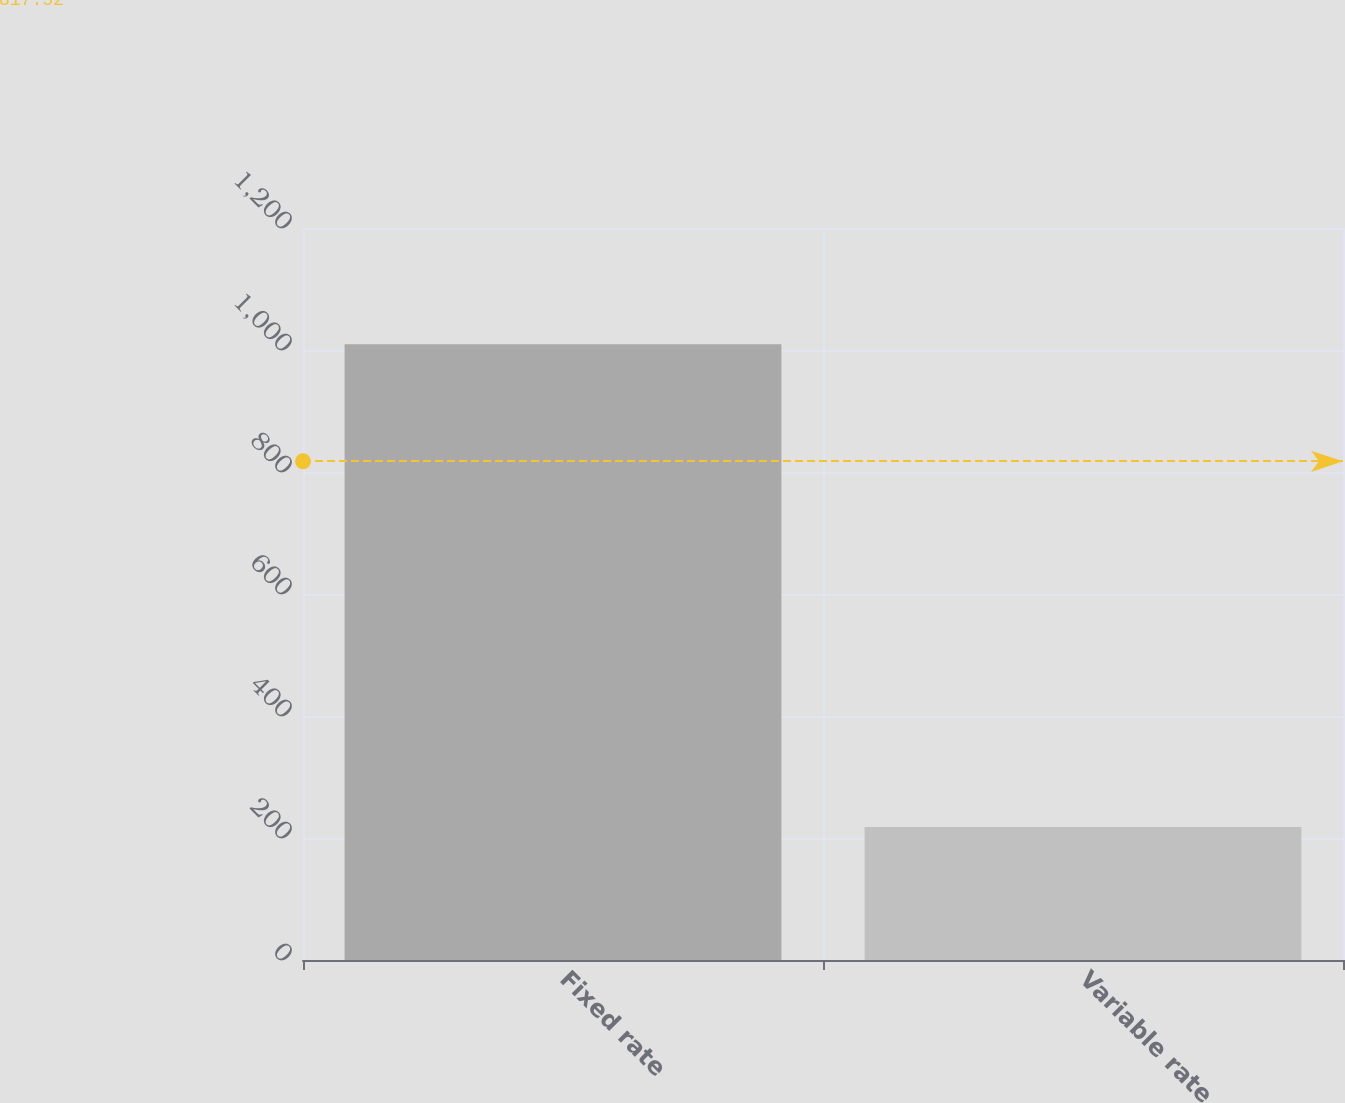Convert chart to OTSL. <chart><loc_0><loc_0><loc_500><loc_500><bar_chart><fcel>Fixed rate<fcel>Variable rate<nl><fcel>1009.5<fcel>217.9<nl></chart> 